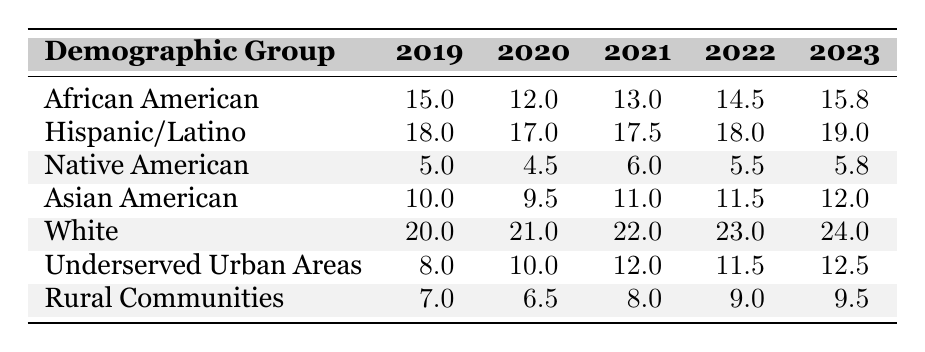What was the funding amount for the Hispanic/Latino demographic in 2020? The table indicates the funding amount for the Hispanic/Latino demographic in 2020 is listed as 17 million.
Answer: 17 million Which demographic group received the lowest funding in 2019? By comparing all the funding amounts for 2019, Native American received the least funding, reported as 5 million.
Answer: Native American What is the total funding received by African American demographics from 2019 to 2023? Summing the funding amounts for African American from 2019 (15 million), 2020 (12 million), 2021 (13 million), 2022 (14.5 million), and 2023 (15.8 million) gives a total of 15 + 12 + 13 + 14.5 + 15.8 = 70.3 million.
Answer: 70.3 million Did the funding for rural communities increase every year from 2019 to 2023? Reviewing the funding amounts shows that rural communities received 7 million in 2019, decreased to 6.5 million in 2020, then increased to 8 million in 2021, 9 million in 2022, and finally 9.5 million in 2023. Since there was a decrease in 2020, the funding did not increase every year.
Answer: No What was the average funding for underserved urban areas over the last five years? The amounts for underserved urban areas are 8 million, 10 million, 12 million, 11.5 million, and 12.5 million. Adding these gives 8 + 10 + 12 + 11.5 + 12.5 = 54 million, and dividing by 5 gives an average of 54 / 5 = 10.8 million.
Answer: 10.8 million Which demographic group saw the largest increase in funding from 2019 to 2023? By calculating the difference between the funding in 2023 and the funding in 2019 for each group, we find: African American (15.8 - 15 = 0.8 million), Hispanic/Latino (19 - 18 = 1 million), Native American (5.8 - 5 = 0.8 million), Asian American (12 - 10 = 2 million), White (24 - 20 = 4 million), Underserved Urban Areas (12.5 - 8 = 4.5 million), and Rural Communities (9.5 - 7 = 2.5 million). White and Underserved Urban Areas both experienced the largest increase of 4.5 million.
Answer: White and Underserved Urban Areas How much more funding did the White demographic group receive compared to the Native American demographic in 2023? In 2023, the White group received 24 million, while the Native American group received 5.8 million. Therefore, the difference is 24 - 5.8 = 18.2 million.
Answer: 18.2 million In which year did the funding for Asian Americans exceed that of Native Americans? Reviewing the table, we find that Asian Americans received more funding than Native Americans in every year from 2019 (10 million vs. 5 million) to 2023 (12 million vs. 5.8 million).
Answer: Every year from 2019 to 2023 What was the overall trend in funding for Native American demographics over the past five years? The funding amounts for Native Americans show: 5 million in 2019, 4.5 million in 2020, 6 million in 2021, 5.5 million in 2022, and 5.8 million in 2023. The trend is not consistent: it decreased from 2019 to 2020, increased in 2021, then slightly decreased in 2022 before increasing again in 2023.
Answer: Fluctuating with no clear trend 